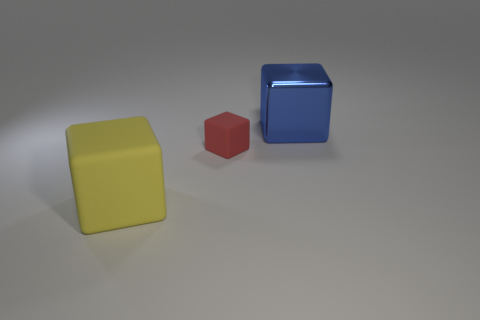Add 1 red matte objects. How many objects exist? 4 Add 2 blue metallic objects. How many blue metallic objects are left? 3 Add 3 green cylinders. How many green cylinders exist? 3 Subtract 0 green cylinders. How many objects are left? 3 Subtract all blue shiny things. Subtract all yellow matte cubes. How many objects are left? 1 